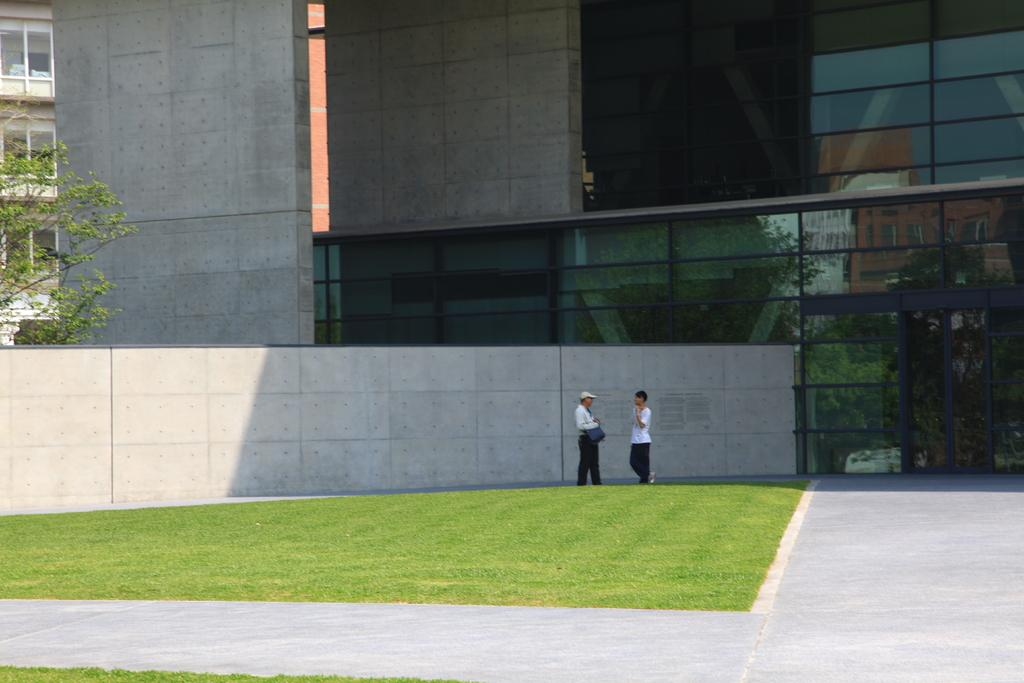What can be seen running through the image? There is a path in the image. What type of vegetation is present in the image? Grass is present in the image. How many people are in the image? There are two persons in the image. What can be seen in the background of the image? There is a wall, a building, and a tree in the background of the image. How many cows are grazing in the image? There are no cows present in the image. What type of light source is illuminating the scene in the image? The image does not provide information about a light source; it only shows the natural light from the sky. 